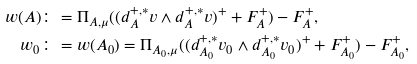Convert formula to latex. <formula><loc_0><loc_0><loc_500><loc_500>w ( A ) & \colon = \Pi _ { A , \mu } ( ( d _ { A } ^ { + , * } v \wedge d _ { A } ^ { + , * } v ) ^ { + } + F _ { A } ^ { + } ) - F _ { A } ^ { + } , \\ w _ { 0 } & \colon = w ( A _ { 0 } ) = \Pi _ { A _ { 0 } , \mu } ( ( d _ { A _ { 0 } } ^ { + , * } v _ { 0 } \wedge d _ { A _ { 0 } } ^ { + , * } v _ { 0 } ) ^ { + } + F _ { A _ { 0 } } ^ { + } ) - F _ { A _ { 0 } } ^ { + } ,</formula> 